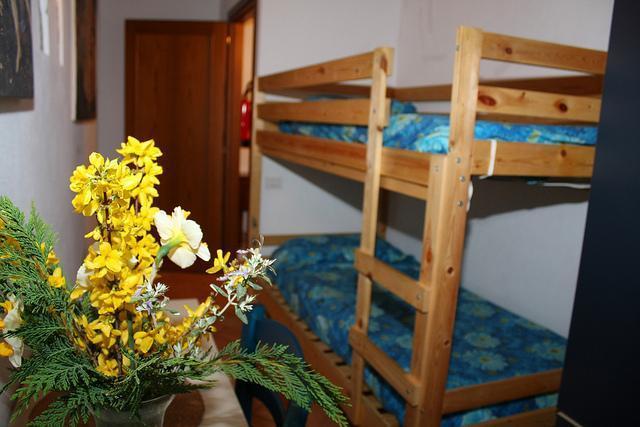How many people is this bed designed for?
Give a very brief answer. 2. How many yellow cups are in the image?
Give a very brief answer. 0. 